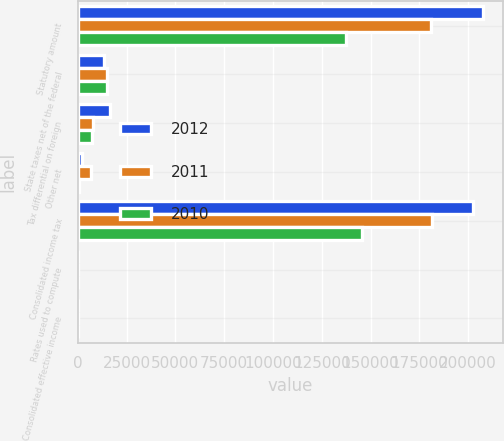<chart> <loc_0><loc_0><loc_500><loc_500><stacked_bar_chart><ecel><fcel>Statutory amount<fcel>State taxes net of the federal<fcel>Tax differential on foreign<fcel>Other net<fcel>Consolidated income tax<fcel>Rates used to compute<fcel>Consolidated effective income<nl><fcel>2012<fcel>207668<fcel>13538<fcel>16667<fcel>2157<fcel>202382<fcel>35<fcel>34.1<nl><fcel>2011<fcel>180831<fcel>15150<fcel>7841<fcel>6700<fcel>181440<fcel>35<fcel>35.1<nl><fcel>2010<fcel>137177<fcel>14821<fcel>7178<fcel>827<fcel>145647<fcel>35<fcel>37.2<nl></chart> 